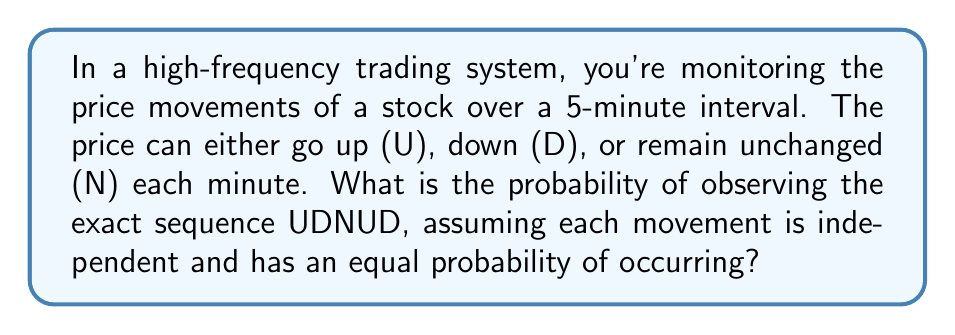Teach me how to tackle this problem. Let's approach this step-by-step:

1) First, we need to understand what we're dealing with:
   - We have 5 independent events (one for each minute)
   - Each event has 3 possible outcomes (U, D, or N)
   - We're looking for a specific sequence (UDNUD)

2) Since each movement is independent and has an equal probability of occurring, the probability of each movement (U, D, or N) is:

   $P(U) = P(D) = P(N) = \frac{1}{3}$

3) Now, we need to calculate the probability of this specific sequence. Since the events are independent, we can multiply the probabilities of each individual event:

   $P(UDNUD) = P(U) \times P(D) \times P(N) \times P(U) \times P(D)$

4) Substituting the probabilities:

   $P(UDNUD) = \frac{1}{3} \times \frac{1}{3} \times \frac{1}{3} \times \frac{1}{3} \times \frac{1}{3}$

5) Simplifying:

   $P(UDNUD) = (\frac{1}{3})^5 = \frac{1}{243}$

Therefore, the probability of observing the exact sequence UDNUD is $\frac{1}{243}$ or approximately 0.00412 or 0.412%.
Answer: $\frac{1}{243}$ 